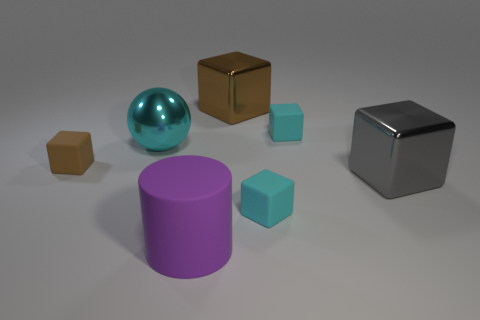Subtract all gray cubes. How many cubes are left? 4 Subtract all red blocks. Subtract all blue spheres. How many blocks are left? 5 Add 3 big brown matte blocks. How many objects exist? 10 Subtract all spheres. How many objects are left? 6 Add 3 large balls. How many large balls are left? 4 Add 6 tiny matte objects. How many tiny matte objects exist? 9 Subtract 0 gray cylinders. How many objects are left? 7 Subtract all small gray spheres. Subtract all small cyan rubber cubes. How many objects are left? 5 